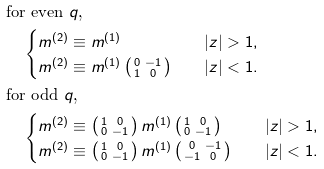<formula> <loc_0><loc_0><loc_500><loc_500>& \text {for even $q$,} \\ & \quad \begin{cases} m ^ { ( 2 ) } \equiv m ^ { ( 1 ) } & \quad | z | > 1 , \\ m ^ { ( 2 ) } \equiv m ^ { ( 1 ) } \left ( \begin{smallmatrix} 0 & - 1 \\ 1 & 0 \end{smallmatrix} \right ) & \quad | z | < 1 . \end{cases} \\ & \text {for odd $q$,} \\ & \quad \begin{cases} m ^ { ( 2 ) } \equiv \left ( \begin{smallmatrix} 1 & 0 \\ 0 & - 1 \end{smallmatrix} \right ) m ^ { ( 1 ) } \left ( \begin{smallmatrix} 1 & 0 \\ 0 & - 1 \end{smallmatrix} \right ) & \quad | z | > 1 , \\ m ^ { ( 2 ) } \equiv \left ( \begin{smallmatrix} 1 & 0 \\ 0 & - 1 \end{smallmatrix} \right ) m ^ { ( 1 ) } \left ( \begin{smallmatrix} 0 & - 1 \\ - 1 & 0 \end{smallmatrix} \right ) & \quad | z | < 1 . \end{cases}</formula> 